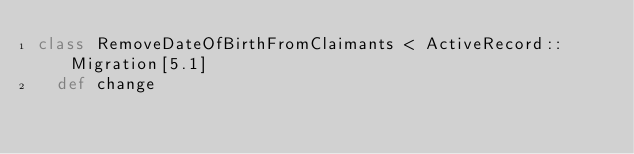Convert code to text. <code><loc_0><loc_0><loc_500><loc_500><_Ruby_>class RemoveDateOfBirthFromClaimants < ActiveRecord::Migration[5.1]
  def change</code> 